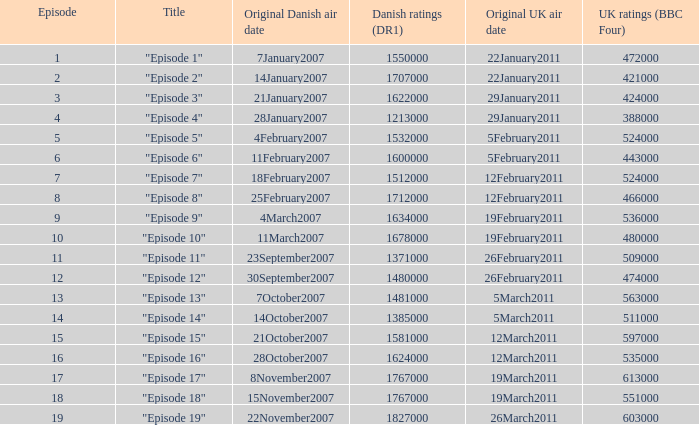What is the original Danish air date of "Episode 17"?  8November2007. 